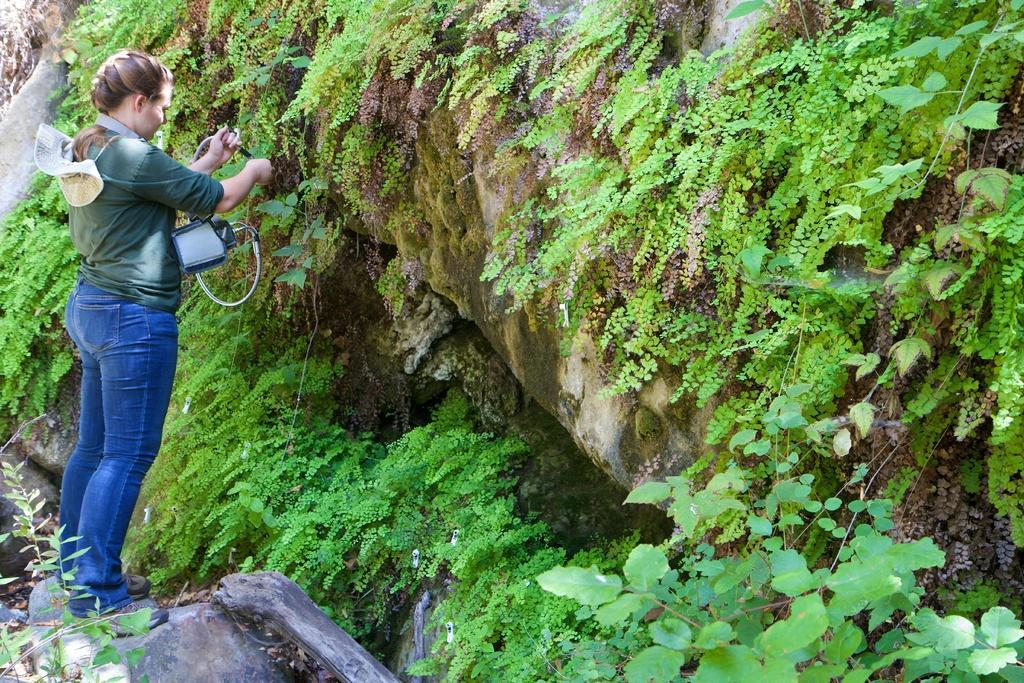Can you describe this image briefly? In this image on the left side there is one woman standing and she is holding some object and doing something and there are rocks and some plants, at the bottom also there are rocks and some dry leaves. 